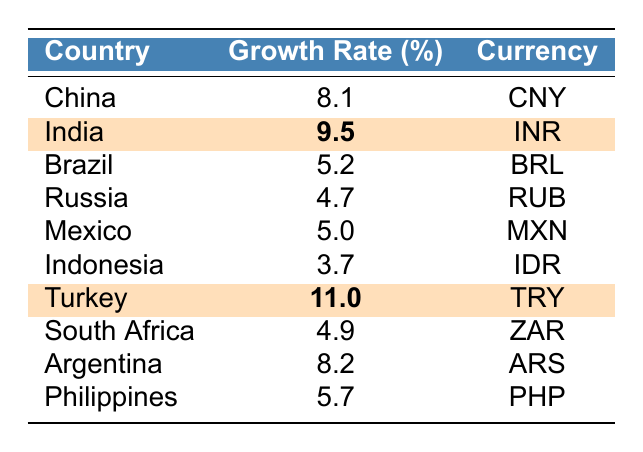What is the highest economic growth rate among the countries listed? Turkey has the highest growth rate of 11.0%, which is clearly indicated in the table among the countries.
Answer: 11.0% Which country has a growth rate of 9.5%? The table highlights India as the country with a growth rate of 9.5%.
Answer: India How many countries have a growth rate higher than 5%? By examining the growth rates, the countries with rates higher than 5% are India (9.5%), Turkey (11.0%), China (8.1%), and Argentina (8.2%). This totals four countries.
Answer: 4 What is the difference in growth rate between Turkey and India? Turkey's growth rate is 11.0% and India's is 9.5%. The difference is calculated as 11.0 - 9.5 = 1.5.
Answer: 1.5% What is the average growth rate of all the countries listed? The growth rates are 8.1, 9.5, 5.2, 4.7, 5.0, 3.7, 11.0, 4.9, 8.2, and 5.7. Adding these gives a total of 56.0. There are 10 countries, so the average is 56.0/10 = 5.6.
Answer: 5.6 Is there a country with a growth rate below 4%? From the data provided, the lowest growth rate is 3.7% (Indonesia), so there is indeed a country below 4%.
Answer: Yes Which emerging market has a growth rate closest to the median value? To find the median, we sort the growth rates which are 3.7, 4.7, 4.9, 5.0, 5.2, 5.7, 8.1, 8.2, 9.5, and 11.0. The middle values (5th and 6th) are 5.2 and 5.7. The median is (5.2 + 5.7)/2 = 5.45. The country closest to this median value is Philippines with a growth rate of 5.7%.
Answer: Philippines Which two countries have growth rates that differ by more than 5%? Turkey (11.0%) and Indonesia (3.7%) have a growth rate difference of 11.0 - 3.7 = 7.3%, which is more than 5%.
Answer: Turkey and Indonesia 